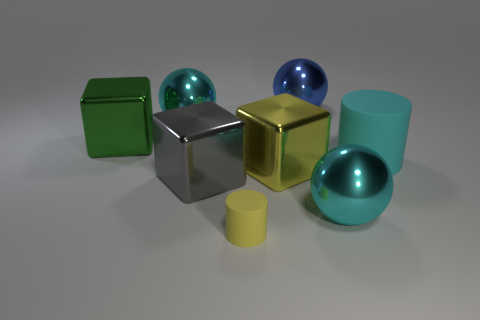What is the shape of the blue object that is the same size as the cyan matte object?
Keep it short and to the point. Sphere. What number of other objects are there of the same color as the large cylinder?
Keep it short and to the point. 2. What is the size of the metal block on the left side of the cyan shiny sphere behind the large cyan matte thing?
Offer a terse response. Large. Do the big cyan sphere that is to the left of the yellow rubber object and the large green object have the same material?
Provide a succinct answer. Yes. What is the shape of the yellow thing behind the tiny yellow rubber object?
Your response must be concise. Cube. How many gray metal cubes are the same size as the blue sphere?
Ensure brevity in your answer.  1. The yellow metal object has what size?
Your response must be concise. Large. How many blue metal objects are in front of the tiny yellow object?
Provide a short and direct response. 0. There is a blue object that is the same material as the large yellow block; what is its shape?
Provide a short and direct response. Sphere. Is the number of yellow shiny things that are left of the yellow metallic object less than the number of large cyan cylinders in front of the small rubber cylinder?
Offer a very short reply. No. 